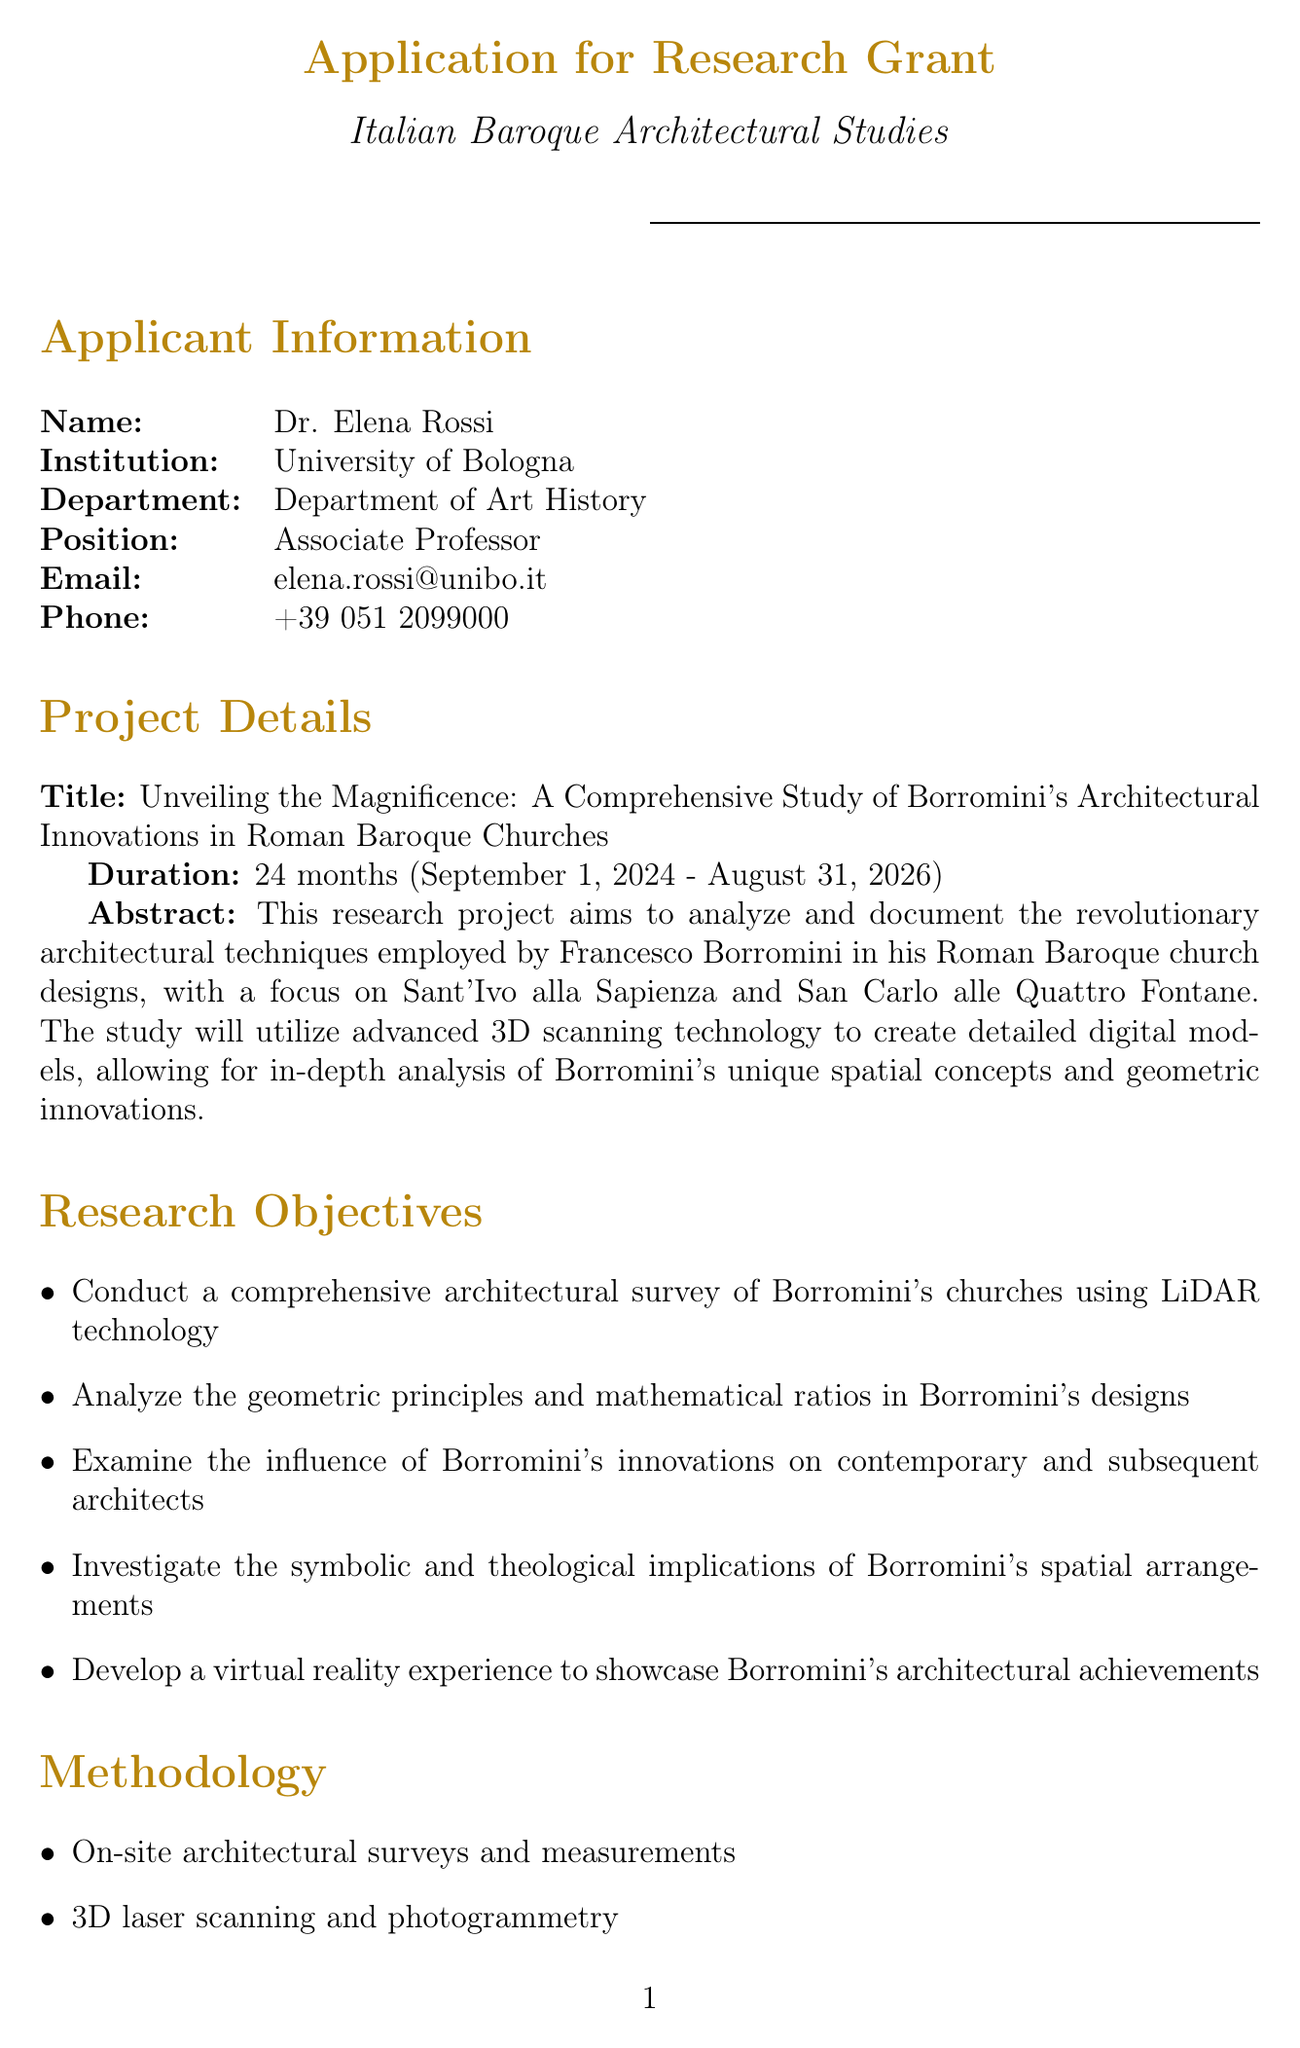What is the title of the project? The title of the project is specified in the document under Project Details.
Answer: Unveiling the Magnificence: A Comprehensive Study of Borromini's Architectural Innovations in Roman Baroque Churches What is the total budget for the research project? The total budget is presented in the Budget Breakdown section of the document.
Answer: €299,200 Who is the Principal Investigator? The Principal Investigator is mentioned in the Personnel Costs table.
Answer: Dr. Elena Rossi How many research trips to Rome are planned? The number of planned research trips is detailed in the Travel Costs section.
Answer: 4 What advanced technology will be used for the architectural surveys? The document mentions the technology to be used in the Methodology section.
Answer: LiDAR technology What is one expected outcome of the research project? Expected outcomes are listed in the Expected Outcomes section, which can be referenced for any item.
Answer: A comprehensive monograph on Borromini's architectural innovations Which institution is collaborating with the University of Bologna? The collaborating institutions are listed in the Collaborating Institutions section.
Answer: Sapienza University of Rome What is the start date of the project? The start date is included under Project Details in the document.
Answer: September 1, 2024 What software licenses are included in other costs? The other costs section lists the specific software licenses that are required.
Answer: AutoCAD, 3ds Max, Unity3D 